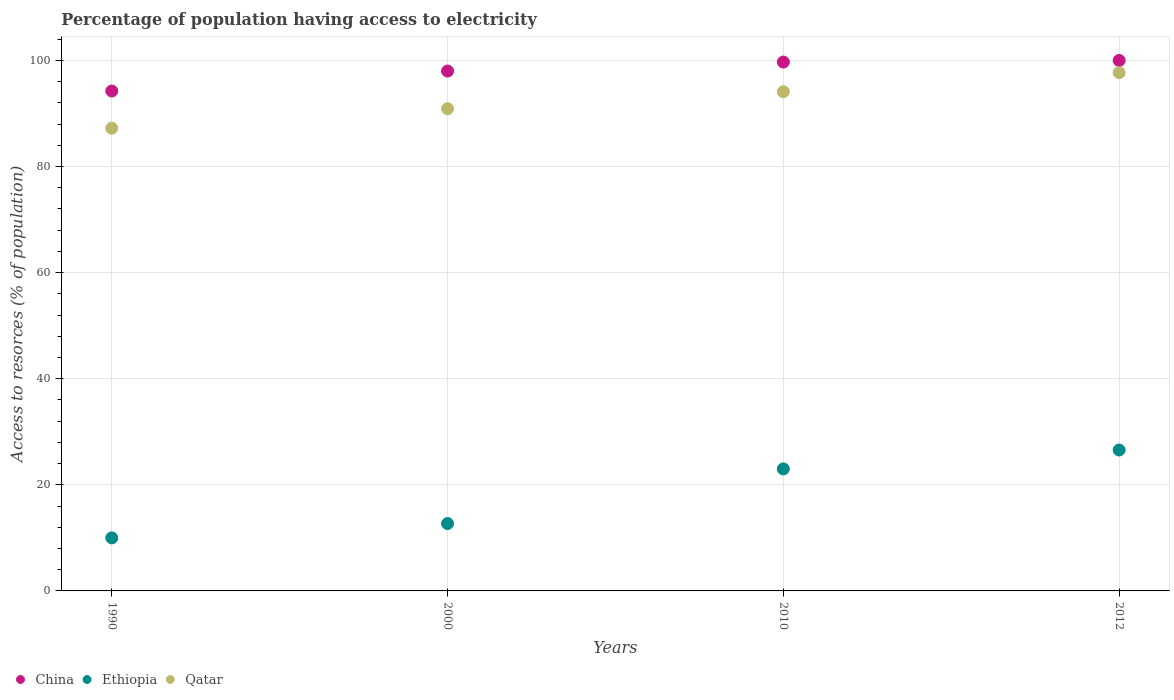Is the number of dotlines equal to the number of legend labels?
Give a very brief answer. Yes. What is the percentage of population having access to electricity in Qatar in 2000?
Make the answer very short. 90.9. Across all years, what is the minimum percentage of population having access to electricity in Qatar?
Offer a very short reply. 87.23. In which year was the percentage of population having access to electricity in China maximum?
Give a very brief answer. 2012. What is the total percentage of population having access to electricity in Ethiopia in the graph?
Your answer should be compact. 72.26. What is the difference between the percentage of population having access to electricity in Qatar in 2010 and that in 2012?
Ensure brevity in your answer.  -3.6. What is the difference between the percentage of population having access to electricity in Qatar in 1990 and the percentage of population having access to electricity in Ethiopia in 2000?
Offer a very short reply. 74.53. What is the average percentage of population having access to electricity in China per year?
Ensure brevity in your answer.  97.98. In the year 1990, what is the difference between the percentage of population having access to electricity in China and percentage of population having access to electricity in Ethiopia?
Provide a short and direct response. 84.24. In how many years, is the percentage of population having access to electricity in China greater than 80 %?
Offer a very short reply. 4. What is the ratio of the percentage of population having access to electricity in China in 2000 to that in 2012?
Your answer should be very brief. 0.98. Is the percentage of population having access to electricity in Ethiopia in 1990 less than that in 2010?
Give a very brief answer. Yes. What is the difference between the highest and the second highest percentage of population having access to electricity in Qatar?
Your answer should be very brief. 3.6. What is the difference between the highest and the lowest percentage of population having access to electricity in Ethiopia?
Your answer should be compact. 16.56. Does the percentage of population having access to electricity in China monotonically increase over the years?
Provide a succinct answer. Yes. Is the percentage of population having access to electricity in Ethiopia strictly greater than the percentage of population having access to electricity in China over the years?
Your response must be concise. No. How many dotlines are there?
Provide a short and direct response. 3. What is the difference between two consecutive major ticks on the Y-axis?
Provide a succinct answer. 20. Does the graph contain any zero values?
Keep it short and to the point. No. Where does the legend appear in the graph?
Your answer should be compact. Bottom left. How many legend labels are there?
Give a very brief answer. 3. What is the title of the graph?
Offer a very short reply. Percentage of population having access to electricity. Does "Cambodia" appear as one of the legend labels in the graph?
Keep it short and to the point. No. What is the label or title of the X-axis?
Provide a succinct answer. Years. What is the label or title of the Y-axis?
Your answer should be very brief. Access to resorces (% of population). What is the Access to resorces (% of population) of China in 1990?
Your response must be concise. 94.24. What is the Access to resorces (% of population) of Ethiopia in 1990?
Offer a terse response. 10. What is the Access to resorces (% of population) of Qatar in 1990?
Give a very brief answer. 87.23. What is the Access to resorces (% of population) in Ethiopia in 2000?
Provide a short and direct response. 12.7. What is the Access to resorces (% of population) of Qatar in 2000?
Keep it short and to the point. 90.9. What is the Access to resorces (% of population) in China in 2010?
Your answer should be compact. 99.7. What is the Access to resorces (% of population) in Qatar in 2010?
Ensure brevity in your answer.  94.1. What is the Access to resorces (% of population) in Ethiopia in 2012?
Make the answer very short. 26.56. What is the Access to resorces (% of population) of Qatar in 2012?
Provide a short and direct response. 97.7. Across all years, what is the maximum Access to resorces (% of population) of China?
Provide a succinct answer. 100. Across all years, what is the maximum Access to resorces (% of population) in Ethiopia?
Keep it short and to the point. 26.56. Across all years, what is the maximum Access to resorces (% of population) of Qatar?
Your response must be concise. 97.7. Across all years, what is the minimum Access to resorces (% of population) in China?
Your response must be concise. 94.24. Across all years, what is the minimum Access to resorces (% of population) of Qatar?
Provide a succinct answer. 87.23. What is the total Access to resorces (% of population) in China in the graph?
Your response must be concise. 391.94. What is the total Access to resorces (% of population) in Ethiopia in the graph?
Make the answer very short. 72.26. What is the total Access to resorces (% of population) of Qatar in the graph?
Keep it short and to the point. 369.92. What is the difference between the Access to resorces (% of population) of China in 1990 and that in 2000?
Give a very brief answer. -3.76. What is the difference between the Access to resorces (% of population) of Ethiopia in 1990 and that in 2000?
Offer a terse response. -2.7. What is the difference between the Access to resorces (% of population) of Qatar in 1990 and that in 2000?
Your response must be concise. -3.67. What is the difference between the Access to resorces (% of population) of China in 1990 and that in 2010?
Provide a succinct answer. -5.46. What is the difference between the Access to resorces (% of population) in Ethiopia in 1990 and that in 2010?
Provide a succinct answer. -13. What is the difference between the Access to resorces (% of population) of Qatar in 1990 and that in 2010?
Your answer should be compact. -6.87. What is the difference between the Access to resorces (% of population) in China in 1990 and that in 2012?
Provide a succinct answer. -5.76. What is the difference between the Access to resorces (% of population) of Ethiopia in 1990 and that in 2012?
Give a very brief answer. -16.56. What is the difference between the Access to resorces (% of population) in Qatar in 1990 and that in 2012?
Offer a very short reply. -10.47. What is the difference between the Access to resorces (% of population) of China in 2000 and that in 2010?
Your answer should be very brief. -1.7. What is the difference between the Access to resorces (% of population) in Qatar in 2000 and that in 2010?
Ensure brevity in your answer.  -3.2. What is the difference between the Access to resorces (% of population) in Ethiopia in 2000 and that in 2012?
Offer a terse response. -13.86. What is the difference between the Access to resorces (% of population) in Qatar in 2000 and that in 2012?
Offer a terse response. -6.8. What is the difference between the Access to resorces (% of population) of Ethiopia in 2010 and that in 2012?
Your answer should be very brief. -3.56. What is the difference between the Access to resorces (% of population) of Qatar in 2010 and that in 2012?
Offer a very short reply. -3.6. What is the difference between the Access to resorces (% of population) in China in 1990 and the Access to resorces (% of population) in Ethiopia in 2000?
Offer a very short reply. 81.54. What is the difference between the Access to resorces (% of population) of China in 1990 and the Access to resorces (% of population) of Qatar in 2000?
Offer a very short reply. 3.34. What is the difference between the Access to resorces (% of population) of Ethiopia in 1990 and the Access to resorces (% of population) of Qatar in 2000?
Your answer should be very brief. -80.9. What is the difference between the Access to resorces (% of population) in China in 1990 and the Access to resorces (% of population) in Ethiopia in 2010?
Your response must be concise. 71.24. What is the difference between the Access to resorces (% of population) of China in 1990 and the Access to resorces (% of population) of Qatar in 2010?
Give a very brief answer. 0.14. What is the difference between the Access to resorces (% of population) in Ethiopia in 1990 and the Access to resorces (% of population) in Qatar in 2010?
Your answer should be very brief. -84.1. What is the difference between the Access to resorces (% of population) in China in 1990 and the Access to resorces (% of population) in Ethiopia in 2012?
Your answer should be very brief. 67.68. What is the difference between the Access to resorces (% of population) of China in 1990 and the Access to resorces (% of population) of Qatar in 2012?
Provide a succinct answer. -3.46. What is the difference between the Access to resorces (% of population) of Ethiopia in 1990 and the Access to resorces (% of population) of Qatar in 2012?
Give a very brief answer. -87.7. What is the difference between the Access to resorces (% of population) in China in 2000 and the Access to resorces (% of population) in Ethiopia in 2010?
Your response must be concise. 75. What is the difference between the Access to resorces (% of population) of Ethiopia in 2000 and the Access to resorces (% of population) of Qatar in 2010?
Ensure brevity in your answer.  -81.4. What is the difference between the Access to resorces (% of population) in China in 2000 and the Access to resorces (% of population) in Ethiopia in 2012?
Provide a succinct answer. 71.44. What is the difference between the Access to resorces (% of population) in China in 2000 and the Access to resorces (% of population) in Qatar in 2012?
Make the answer very short. 0.3. What is the difference between the Access to resorces (% of population) of Ethiopia in 2000 and the Access to resorces (% of population) of Qatar in 2012?
Your answer should be compact. -85. What is the difference between the Access to resorces (% of population) in China in 2010 and the Access to resorces (% of population) in Ethiopia in 2012?
Provide a short and direct response. 73.14. What is the difference between the Access to resorces (% of population) of China in 2010 and the Access to resorces (% of population) of Qatar in 2012?
Keep it short and to the point. 2. What is the difference between the Access to resorces (% of population) in Ethiopia in 2010 and the Access to resorces (% of population) in Qatar in 2012?
Offer a very short reply. -74.7. What is the average Access to resorces (% of population) of China per year?
Give a very brief answer. 97.98. What is the average Access to resorces (% of population) in Ethiopia per year?
Give a very brief answer. 18.07. What is the average Access to resorces (% of population) of Qatar per year?
Ensure brevity in your answer.  92.48. In the year 1990, what is the difference between the Access to resorces (% of population) in China and Access to resorces (% of population) in Ethiopia?
Your answer should be compact. 84.24. In the year 1990, what is the difference between the Access to resorces (% of population) of China and Access to resorces (% of population) of Qatar?
Keep it short and to the point. 7.01. In the year 1990, what is the difference between the Access to resorces (% of population) in Ethiopia and Access to resorces (% of population) in Qatar?
Keep it short and to the point. -77.23. In the year 2000, what is the difference between the Access to resorces (% of population) of China and Access to resorces (% of population) of Ethiopia?
Provide a short and direct response. 85.3. In the year 2000, what is the difference between the Access to resorces (% of population) of China and Access to resorces (% of population) of Qatar?
Your answer should be very brief. 7.1. In the year 2000, what is the difference between the Access to resorces (% of population) in Ethiopia and Access to resorces (% of population) in Qatar?
Your answer should be compact. -78.2. In the year 2010, what is the difference between the Access to resorces (% of population) of China and Access to resorces (% of population) of Ethiopia?
Your answer should be compact. 76.7. In the year 2010, what is the difference between the Access to resorces (% of population) in China and Access to resorces (% of population) in Qatar?
Your response must be concise. 5.6. In the year 2010, what is the difference between the Access to resorces (% of population) of Ethiopia and Access to resorces (% of population) of Qatar?
Keep it short and to the point. -71.1. In the year 2012, what is the difference between the Access to resorces (% of population) in China and Access to resorces (% of population) in Ethiopia?
Keep it short and to the point. 73.44. In the year 2012, what is the difference between the Access to resorces (% of population) in China and Access to resorces (% of population) in Qatar?
Provide a short and direct response. 2.3. In the year 2012, what is the difference between the Access to resorces (% of population) in Ethiopia and Access to resorces (% of population) in Qatar?
Offer a very short reply. -71.14. What is the ratio of the Access to resorces (% of population) in China in 1990 to that in 2000?
Give a very brief answer. 0.96. What is the ratio of the Access to resorces (% of population) in Ethiopia in 1990 to that in 2000?
Provide a short and direct response. 0.79. What is the ratio of the Access to resorces (% of population) in Qatar in 1990 to that in 2000?
Your response must be concise. 0.96. What is the ratio of the Access to resorces (% of population) of China in 1990 to that in 2010?
Provide a short and direct response. 0.95. What is the ratio of the Access to resorces (% of population) in Ethiopia in 1990 to that in 2010?
Ensure brevity in your answer.  0.43. What is the ratio of the Access to resorces (% of population) of Qatar in 1990 to that in 2010?
Keep it short and to the point. 0.93. What is the ratio of the Access to resorces (% of population) in China in 1990 to that in 2012?
Your answer should be very brief. 0.94. What is the ratio of the Access to resorces (% of population) of Ethiopia in 1990 to that in 2012?
Provide a succinct answer. 0.38. What is the ratio of the Access to resorces (% of population) in Qatar in 1990 to that in 2012?
Offer a very short reply. 0.89. What is the ratio of the Access to resorces (% of population) of China in 2000 to that in 2010?
Provide a succinct answer. 0.98. What is the ratio of the Access to resorces (% of population) in Ethiopia in 2000 to that in 2010?
Offer a terse response. 0.55. What is the ratio of the Access to resorces (% of population) in Ethiopia in 2000 to that in 2012?
Offer a terse response. 0.48. What is the ratio of the Access to resorces (% of population) of Qatar in 2000 to that in 2012?
Give a very brief answer. 0.93. What is the ratio of the Access to resorces (% of population) of China in 2010 to that in 2012?
Give a very brief answer. 1. What is the ratio of the Access to resorces (% of population) of Ethiopia in 2010 to that in 2012?
Provide a succinct answer. 0.87. What is the ratio of the Access to resorces (% of population) of Qatar in 2010 to that in 2012?
Keep it short and to the point. 0.96. What is the difference between the highest and the second highest Access to resorces (% of population) in Ethiopia?
Provide a short and direct response. 3.56. What is the difference between the highest and the second highest Access to resorces (% of population) in Qatar?
Give a very brief answer. 3.6. What is the difference between the highest and the lowest Access to resorces (% of population) of China?
Your response must be concise. 5.76. What is the difference between the highest and the lowest Access to resorces (% of population) of Ethiopia?
Your answer should be compact. 16.56. What is the difference between the highest and the lowest Access to resorces (% of population) in Qatar?
Your answer should be very brief. 10.47. 